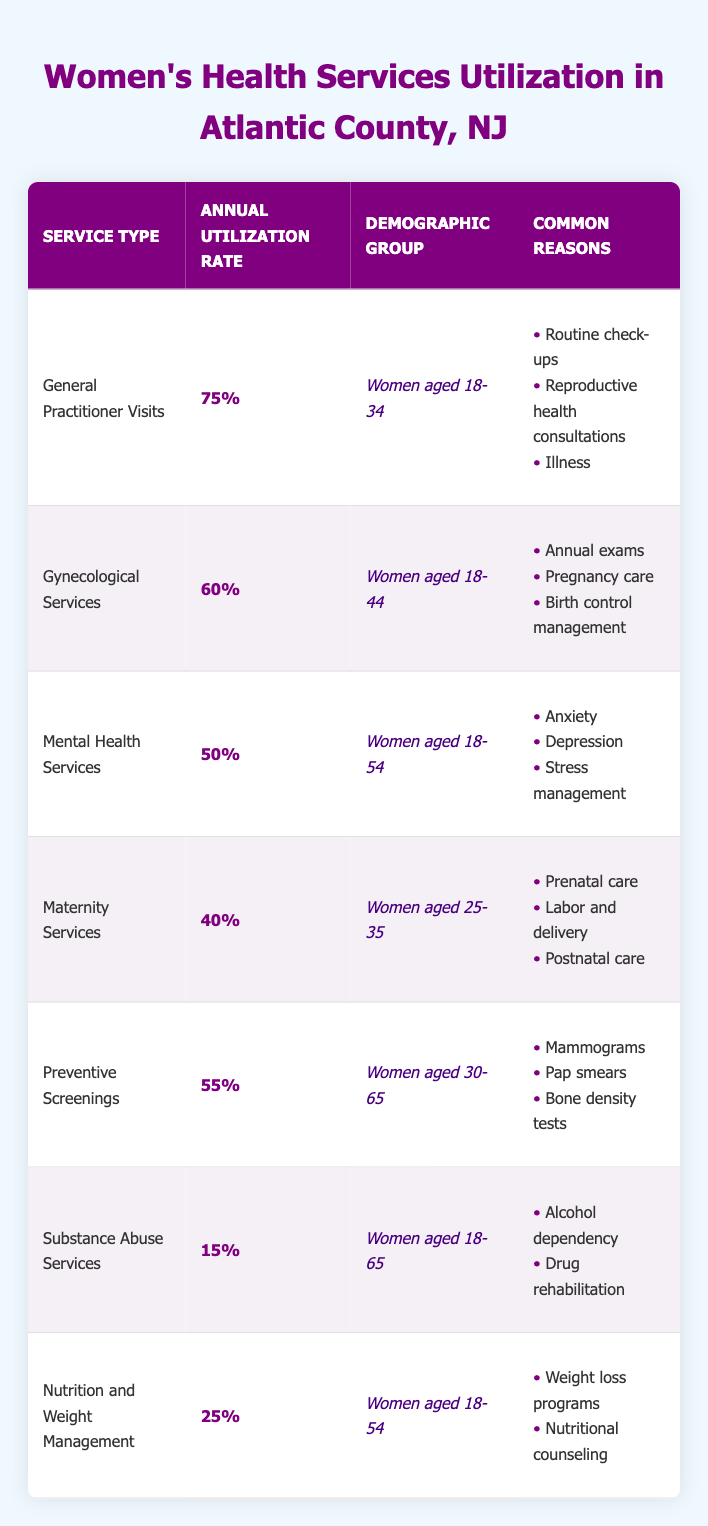What is the annual utilization rate of General Practitioner Visits? The table shows that the annual utilization rate for General Practitioner Visits is listed directly next to the service type. The value is 75%, which can be found in the second column of the corresponding row.
Answer: 75% Which demographic group uses Gynecological Services the most? The demographic group using Gynecological Services is specified in the third column of the corresponding row, which indicates "Women aged 18-44." This is a direct retrieval from the table.
Answer: Women aged 18-44 What is the average annual utilization rate of Mental Health Services and Substance Abuse Services combined? To find the average, first sum the utilization rates of both services: Mental Health Services (50%) + Substance Abuse Services (15%) = 65%. Then, divide by 2: 65% / 2 = 32.5%. This involves a mathematical operation applied to the two relevant entries.
Answer: 32.5% Is the annual utilization rate for Maternity Services greater than the utilization rate for Nutrition and Weight Management? Comparing the two rates shows Maternity Services at 40% and Nutrition and Weight Management at 25%. Since 40% is greater than 25%, the answer is yes. This requires a straightforward comparison of the two data points from the respective rows.
Answer: Yes How many services have an annual utilization rate of 50% or higher? By counting the number of services in the table with an annual utilization rate of 50% or more, we find: General Practitioner Visits (75%), Gynecological Services (60%), Mental Health Services (50%), and Preventive Screenings (55%). This totals to 4 services, ensuring clarity in combining qualitative data from several rows.
Answer: 4 What is the total annual utilization rate of services for women aged 18-54? For this demographic, we consider the services listed: Mental Health Services (50%) and Nutrition and Weight Management (25%). The total is: 50% + 25% = 75%. This requires adding the utilization rates from multiple rows specific to this age group.
Answer: 75% Do women aged 30-65 utilize Preventive Screenings at a higher rate than women aged 18-34 utilize General Practitioner Visits? The annual utilization rate for Preventive Screenings for women aged 30-65 is 55%, while for women aged 18-34, it is 75%. Since 55% is less than 75%, the answer is no. This requires comparing the two specific rates to determine the factual correctness.
Answer: No What percentage of women utilize Substance Abuse Services compared to those utilizing Maternity Services? The utilization rate for Substance Abuse Services is 15%, and for Maternity Services, it is 40%. To find the percentage comparison, it can be noted that 15% is much less than 40%, which is a comparison highlighting the disparity between the two rates.
Answer: 15% is less than 40% 